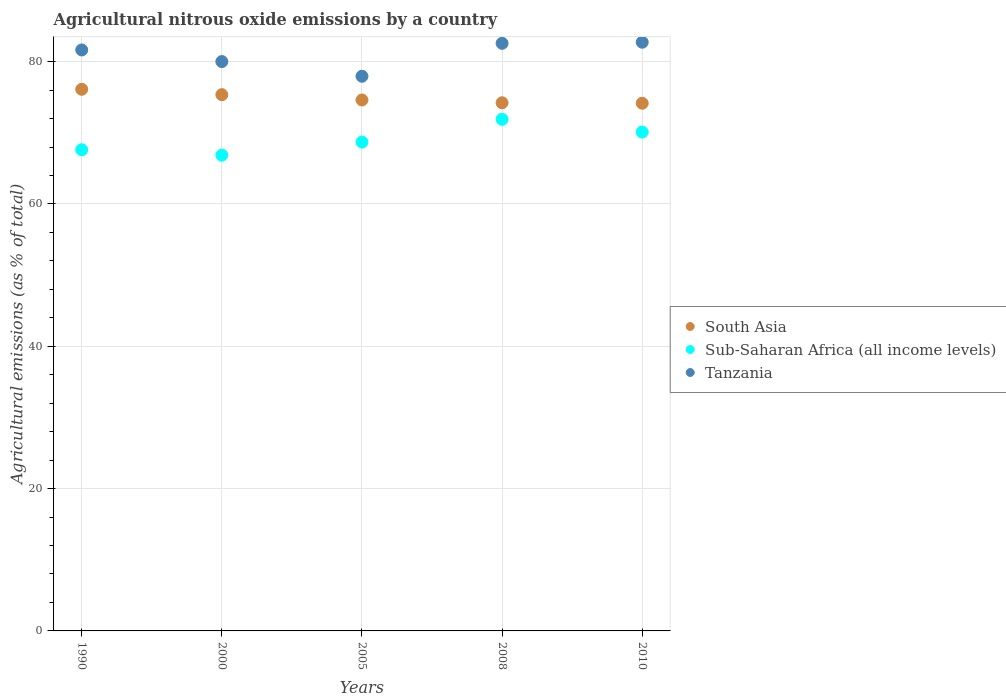How many different coloured dotlines are there?
Keep it short and to the point. 3. Is the number of dotlines equal to the number of legend labels?
Provide a short and direct response. Yes. What is the amount of agricultural nitrous oxide emitted in Sub-Saharan Africa (all income levels) in 2000?
Make the answer very short. 66.86. Across all years, what is the maximum amount of agricultural nitrous oxide emitted in South Asia?
Provide a short and direct response. 76.12. Across all years, what is the minimum amount of agricultural nitrous oxide emitted in Sub-Saharan Africa (all income levels)?
Provide a short and direct response. 66.86. In which year was the amount of agricultural nitrous oxide emitted in Sub-Saharan Africa (all income levels) maximum?
Your answer should be compact. 2008. What is the total amount of agricultural nitrous oxide emitted in South Asia in the graph?
Give a very brief answer. 374.48. What is the difference between the amount of agricultural nitrous oxide emitted in Sub-Saharan Africa (all income levels) in 2008 and that in 2010?
Give a very brief answer. 1.79. What is the difference between the amount of agricultural nitrous oxide emitted in Sub-Saharan Africa (all income levels) in 2005 and the amount of agricultural nitrous oxide emitted in Tanzania in 1990?
Your answer should be compact. -12.95. What is the average amount of agricultural nitrous oxide emitted in Sub-Saharan Africa (all income levels) per year?
Your answer should be compact. 69.04. In the year 2000, what is the difference between the amount of agricultural nitrous oxide emitted in Tanzania and amount of agricultural nitrous oxide emitted in South Asia?
Your answer should be very brief. 4.65. What is the ratio of the amount of agricultural nitrous oxide emitted in Tanzania in 2000 to that in 2005?
Your response must be concise. 1.03. Is the difference between the amount of agricultural nitrous oxide emitted in Tanzania in 1990 and 2000 greater than the difference between the amount of agricultural nitrous oxide emitted in South Asia in 1990 and 2000?
Your answer should be compact. Yes. What is the difference between the highest and the second highest amount of agricultural nitrous oxide emitted in South Asia?
Offer a very short reply. 0.76. What is the difference between the highest and the lowest amount of agricultural nitrous oxide emitted in South Asia?
Keep it short and to the point. 1.96. In how many years, is the amount of agricultural nitrous oxide emitted in Sub-Saharan Africa (all income levels) greater than the average amount of agricultural nitrous oxide emitted in Sub-Saharan Africa (all income levels) taken over all years?
Provide a short and direct response. 2. Does the amount of agricultural nitrous oxide emitted in Tanzania monotonically increase over the years?
Your response must be concise. No. Is the amount of agricultural nitrous oxide emitted in Sub-Saharan Africa (all income levels) strictly less than the amount of agricultural nitrous oxide emitted in South Asia over the years?
Give a very brief answer. Yes. How many dotlines are there?
Ensure brevity in your answer.  3. Are the values on the major ticks of Y-axis written in scientific E-notation?
Provide a succinct answer. No. Does the graph contain grids?
Provide a short and direct response. Yes. Where does the legend appear in the graph?
Offer a very short reply. Center right. How many legend labels are there?
Make the answer very short. 3. What is the title of the graph?
Your answer should be very brief. Agricultural nitrous oxide emissions by a country. Does "Faeroe Islands" appear as one of the legend labels in the graph?
Provide a succinct answer. No. What is the label or title of the Y-axis?
Keep it short and to the point. Agricultural emissions (as % of total). What is the Agricultural emissions (as % of total) of South Asia in 1990?
Your answer should be very brief. 76.12. What is the Agricultural emissions (as % of total) in Sub-Saharan Africa (all income levels) in 1990?
Your response must be concise. 67.62. What is the Agricultural emissions (as % of total) in Tanzania in 1990?
Your response must be concise. 81.65. What is the Agricultural emissions (as % of total) in South Asia in 2000?
Your response must be concise. 75.36. What is the Agricultural emissions (as % of total) in Sub-Saharan Africa (all income levels) in 2000?
Your answer should be compact. 66.86. What is the Agricultural emissions (as % of total) in Tanzania in 2000?
Make the answer very short. 80.01. What is the Agricultural emissions (as % of total) in South Asia in 2005?
Your answer should be compact. 74.62. What is the Agricultural emissions (as % of total) of Sub-Saharan Africa (all income levels) in 2005?
Provide a short and direct response. 68.7. What is the Agricultural emissions (as % of total) in Tanzania in 2005?
Your response must be concise. 77.95. What is the Agricultural emissions (as % of total) of South Asia in 2008?
Provide a short and direct response. 74.22. What is the Agricultural emissions (as % of total) of Sub-Saharan Africa (all income levels) in 2008?
Keep it short and to the point. 71.9. What is the Agricultural emissions (as % of total) of Tanzania in 2008?
Give a very brief answer. 82.58. What is the Agricultural emissions (as % of total) in South Asia in 2010?
Provide a short and direct response. 74.16. What is the Agricultural emissions (as % of total) of Sub-Saharan Africa (all income levels) in 2010?
Provide a short and direct response. 70.1. What is the Agricultural emissions (as % of total) in Tanzania in 2010?
Offer a terse response. 82.73. Across all years, what is the maximum Agricultural emissions (as % of total) in South Asia?
Give a very brief answer. 76.12. Across all years, what is the maximum Agricultural emissions (as % of total) of Sub-Saharan Africa (all income levels)?
Offer a terse response. 71.9. Across all years, what is the maximum Agricultural emissions (as % of total) of Tanzania?
Provide a short and direct response. 82.73. Across all years, what is the minimum Agricultural emissions (as % of total) of South Asia?
Your answer should be compact. 74.16. Across all years, what is the minimum Agricultural emissions (as % of total) in Sub-Saharan Africa (all income levels)?
Give a very brief answer. 66.86. Across all years, what is the minimum Agricultural emissions (as % of total) in Tanzania?
Provide a succinct answer. 77.95. What is the total Agricultural emissions (as % of total) of South Asia in the graph?
Ensure brevity in your answer.  374.48. What is the total Agricultural emissions (as % of total) in Sub-Saharan Africa (all income levels) in the graph?
Provide a short and direct response. 345.18. What is the total Agricultural emissions (as % of total) in Tanzania in the graph?
Offer a terse response. 404.92. What is the difference between the Agricultural emissions (as % of total) of South Asia in 1990 and that in 2000?
Offer a terse response. 0.76. What is the difference between the Agricultural emissions (as % of total) of Sub-Saharan Africa (all income levels) in 1990 and that in 2000?
Offer a very short reply. 0.76. What is the difference between the Agricultural emissions (as % of total) of Tanzania in 1990 and that in 2000?
Your answer should be very brief. 1.63. What is the difference between the Agricultural emissions (as % of total) in South Asia in 1990 and that in 2005?
Keep it short and to the point. 1.5. What is the difference between the Agricultural emissions (as % of total) in Sub-Saharan Africa (all income levels) in 1990 and that in 2005?
Offer a terse response. -1.08. What is the difference between the Agricultural emissions (as % of total) of Tanzania in 1990 and that in 2005?
Keep it short and to the point. 3.7. What is the difference between the Agricultural emissions (as % of total) of South Asia in 1990 and that in 2008?
Your response must be concise. 1.9. What is the difference between the Agricultural emissions (as % of total) in Sub-Saharan Africa (all income levels) in 1990 and that in 2008?
Provide a succinct answer. -4.28. What is the difference between the Agricultural emissions (as % of total) in Tanzania in 1990 and that in 2008?
Offer a terse response. -0.93. What is the difference between the Agricultural emissions (as % of total) in South Asia in 1990 and that in 2010?
Give a very brief answer. 1.96. What is the difference between the Agricultural emissions (as % of total) in Sub-Saharan Africa (all income levels) in 1990 and that in 2010?
Your answer should be compact. -2.48. What is the difference between the Agricultural emissions (as % of total) of Tanzania in 1990 and that in 2010?
Provide a short and direct response. -1.08. What is the difference between the Agricultural emissions (as % of total) in South Asia in 2000 and that in 2005?
Your answer should be compact. 0.75. What is the difference between the Agricultural emissions (as % of total) in Sub-Saharan Africa (all income levels) in 2000 and that in 2005?
Your answer should be compact. -1.84. What is the difference between the Agricultural emissions (as % of total) of Tanzania in 2000 and that in 2005?
Offer a terse response. 2.07. What is the difference between the Agricultural emissions (as % of total) of South Asia in 2000 and that in 2008?
Provide a succinct answer. 1.14. What is the difference between the Agricultural emissions (as % of total) of Sub-Saharan Africa (all income levels) in 2000 and that in 2008?
Give a very brief answer. -5.04. What is the difference between the Agricultural emissions (as % of total) of Tanzania in 2000 and that in 2008?
Give a very brief answer. -2.56. What is the difference between the Agricultural emissions (as % of total) in South Asia in 2000 and that in 2010?
Ensure brevity in your answer.  1.2. What is the difference between the Agricultural emissions (as % of total) of Sub-Saharan Africa (all income levels) in 2000 and that in 2010?
Your answer should be very brief. -3.24. What is the difference between the Agricultural emissions (as % of total) in Tanzania in 2000 and that in 2010?
Your answer should be very brief. -2.72. What is the difference between the Agricultural emissions (as % of total) in South Asia in 2005 and that in 2008?
Your answer should be very brief. 0.39. What is the difference between the Agricultural emissions (as % of total) of Sub-Saharan Africa (all income levels) in 2005 and that in 2008?
Offer a very short reply. -3.2. What is the difference between the Agricultural emissions (as % of total) in Tanzania in 2005 and that in 2008?
Offer a terse response. -4.63. What is the difference between the Agricultural emissions (as % of total) in South Asia in 2005 and that in 2010?
Your answer should be compact. 0.46. What is the difference between the Agricultural emissions (as % of total) of Sub-Saharan Africa (all income levels) in 2005 and that in 2010?
Offer a terse response. -1.41. What is the difference between the Agricultural emissions (as % of total) of Tanzania in 2005 and that in 2010?
Your answer should be compact. -4.79. What is the difference between the Agricultural emissions (as % of total) in South Asia in 2008 and that in 2010?
Make the answer very short. 0.06. What is the difference between the Agricultural emissions (as % of total) of Sub-Saharan Africa (all income levels) in 2008 and that in 2010?
Provide a succinct answer. 1.79. What is the difference between the Agricultural emissions (as % of total) of Tanzania in 2008 and that in 2010?
Offer a very short reply. -0.15. What is the difference between the Agricultural emissions (as % of total) of South Asia in 1990 and the Agricultural emissions (as % of total) of Sub-Saharan Africa (all income levels) in 2000?
Provide a short and direct response. 9.26. What is the difference between the Agricultural emissions (as % of total) in South Asia in 1990 and the Agricultural emissions (as % of total) in Tanzania in 2000?
Provide a short and direct response. -3.9. What is the difference between the Agricultural emissions (as % of total) of Sub-Saharan Africa (all income levels) in 1990 and the Agricultural emissions (as % of total) of Tanzania in 2000?
Make the answer very short. -12.39. What is the difference between the Agricultural emissions (as % of total) of South Asia in 1990 and the Agricultural emissions (as % of total) of Sub-Saharan Africa (all income levels) in 2005?
Offer a very short reply. 7.42. What is the difference between the Agricultural emissions (as % of total) of South Asia in 1990 and the Agricultural emissions (as % of total) of Tanzania in 2005?
Your response must be concise. -1.83. What is the difference between the Agricultural emissions (as % of total) in Sub-Saharan Africa (all income levels) in 1990 and the Agricultural emissions (as % of total) in Tanzania in 2005?
Provide a short and direct response. -10.33. What is the difference between the Agricultural emissions (as % of total) in South Asia in 1990 and the Agricultural emissions (as % of total) in Sub-Saharan Africa (all income levels) in 2008?
Your answer should be compact. 4.22. What is the difference between the Agricultural emissions (as % of total) of South Asia in 1990 and the Agricultural emissions (as % of total) of Tanzania in 2008?
Keep it short and to the point. -6.46. What is the difference between the Agricultural emissions (as % of total) of Sub-Saharan Africa (all income levels) in 1990 and the Agricultural emissions (as % of total) of Tanzania in 2008?
Offer a very short reply. -14.96. What is the difference between the Agricultural emissions (as % of total) of South Asia in 1990 and the Agricultural emissions (as % of total) of Sub-Saharan Africa (all income levels) in 2010?
Your answer should be very brief. 6.02. What is the difference between the Agricultural emissions (as % of total) in South Asia in 1990 and the Agricultural emissions (as % of total) in Tanzania in 2010?
Your answer should be very brief. -6.61. What is the difference between the Agricultural emissions (as % of total) in Sub-Saharan Africa (all income levels) in 1990 and the Agricultural emissions (as % of total) in Tanzania in 2010?
Provide a short and direct response. -15.11. What is the difference between the Agricultural emissions (as % of total) of South Asia in 2000 and the Agricultural emissions (as % of total) of Sub-Saharan Africa (all income levels) in 2005?
Offer a terse response. 6.67. What is the difference between the Agricultural emissions (as % of total) of South Asia in 2000 and the Agricultural emissions (as % of total) of Tanzania in 2005?
Your answer should be compact. -2.58. What is the difference between the Agricultural emissions (as % of total) of Sub-Saharan Africa (all income levels) in 2000 and the Agricultural emissions (as % of total) of Tanzania in 2005?
Keep it short and to the point. -11.09. What is the difference between the Agricultural emissions (as % of total) in South Asia in 2000 and the Agricultural emissions (as % of total) in Sub-Saharan Africa (all income levels) in 2008?
Provide a short and direct response. 3.46. What is the difference between the Agricultural emissions (as % of total) of South Asia in 2000 and the Agricultural emissions (as % of total) of Tanzania in 2008?
Offer a very short reply. -7.22. What is the difference between the Agricultural emissions (as % of total) in Sub-Saharan Africa (all income levels) in 2000 and the Agricultural emissions (as % of total) in Tanzania in 2008?
Your response must be concise. -15.72. What is the difference between the Agricultural emissions (as % of total) in South Asia in 2000 and the Agricultural emissions (as % of total) in Sub-Saharan Africa (all income levels) in 2010?
Provide a succinct answer. 5.26. What is the difference between the Agricultural emissions (as % of total) in South Asia in 2000 and the Agricultural emissions (as % of total) in Tanzania in 2010?
Make the answer very short. -7.37. What is the difference between the Agricultural emissions (as % of total) in Sub-Saharan Africa (all income levels) in 2000 and the Agricultural emissions (as % of total) in Tanzania in 2010?
Keep it short and to the point. -15.87. What is the difference between the Agricultural emissions (as % of total) in South Asia in 2005 and the Agricultural emissions (as % of total) in Sub-Saharan Africa (all income levels) in 2008?
Your answer should be compact. 2.72. What is the difference between the Agricultural emissions (as % of total) in South Asia in 2005 and the Agricultural emissions (as % of total) in Tanzania in 2008?
Offer a very short reply. -7.96. What is the difference between the Agricultural emissions (as % of total) in Sub-Saharan Africa (all income levels) in 2005 and the Agricultural emissions (as % of total) in Tanzania in 2008?
Ensure brevity in your answer.  -13.88. What is the difference between the Agricultural emissions (as % of total) of South Asia in 2005 and the Agricultural emissions (as % of total) of Sub-Saharan Africa (all income levels) in 2010?
Ensure brevity in your answer.  4.51. What is the difference between the Agricultural emissions (as % of total) of South Asia in 2005 and the Agricultural emissions (as % of total) of Tanzania in 2010?
Make the answer very short. -8.12. What is the difference between the Agricultural emissions (as % of total) of Sub-Saharan Africa (all income levels) in 2005 and the Agricultural emissions (as % of total) of Tanzania in 2010?
Your answer should be very brief. -14.04. What is the difference between the Agricultural emissions (as % of total) in South Asia in 2008 and the Agricultural emissions (as % of total) in Sub-Saharan Africa (all income levels) in 2010?
Provide a succinct answer. 4.12. What is the difference between the Agricultural emissions (as % of total) of South Asia in 2008 and the Agricultural emissions (as % of total) of Tanzania in 2010?
Ensure brevity in your answer.  -8.51. What is the difference between the Agricultural emissions (as % of total) of Sub-Saharan Africa (all income levels) in 2008 and the Agricultural emissions (as % of total) of Tanzania in 2010?
Your response must be concise. -10.83. What is the average Agricultural emissions (as % of total) of South Asia per year?
Make the answer very short. 74.9. What is the average Agricultural emissions (as % of total) in Sub-Saharan Africa (all income levels) per year?
Your answer should be compact. 69.04. What is the average Agricultural emissions (as % of total) of Tanzania per year?
Your answer should be very brief. 80.98. In the year 1990, what is the difference between the Agricultural emissions (as % of total) in South Asia and Agricultural emissions (as % of total) in Sub-Saharan Africa (all income levels)?
Offer a terse response. 8.5. In the year 1990, what is the difference between the Agricultural emissions (as % of total) in South Asia and Agricultural emissions (as % of total) in Tanzania?
Offer a terse response. -5.53. In the year 1990, what is the difference between the Agricultural emissions (as % of total) in Sub-Saharan Africa (all income levels) and Agricultural emissions (as % of total) in Tanzania?
Keep it short and to the point. -14.03. In the year 2000, what is the difference between the Agricultural emissions (as % of total) of South Asia and Agricultural emissions (as % of total) of Sub-Saharan Africa (all income levels)?
Your answer should be very brief. 8.5. In the year 2000, what is the difference between the Agricultural emissions (as % of total) in South Asia and Agricultural emissions (as % of total) in Tanzania?
Your answer should be compact. -4.65. In the year 2000, what is the difference between the Agricultural emissions (as % of total) in Sub-Saharan Africa (all income levels) and Agricultural emissions (as % of total) in Tanzania?
Offer a very short reply. -13.16. In the year 2005, what is the difference between the Agricultural emissions (as % of total) in South Asia and Agricultural emissions (as % of total) in Sub-Saharan Africa (all income levels)?
Offer a terse response. 5.92. In the year 2005, what is the difference between the Agricultural emissions (as % of total) of South Asia and Agricultural emissions (as % of total) of Tanzania?
Give a very brief answer. -3.33. In the year 2005, what is the difference between the Agricultural emissions (as % of total) in Sub-Saharan Africa (all income levels) and Agricultural emissions (as % of total) in Tanzania?
Ensure brevity in your answer.  -9.25. In the year 2008, what is the difference between the Agricultural emissions (as % of total) in South Asia and Agricultural emissions (as % of total) in Sub-Saharan Africa (all income levels)?
Your answer should be very brief. 2.32. In the year 2008, what is the difference between the Agricultural emissions (as % of total) of South Asia and Agricultural emissions (as % of total) of Tanzania?
Your answer should be very brief. -8.36. In the year 2008, what is the difference between the Agricultural emissions (as % of total) of Sub-Saharan Africa (all income levels) and Agricultural emissions (as % of total) of Tanzania?
Make the answer very short. -10.68. In the year 2010, what is the difference between the Agricultural emissions (as % of total) of South Asia and Agricultural emissions (as % of total) of Sub-Saharan Africa (all income levels)?
Make the answer very short. 4.06. In the year 2010, what is the difference between the Agricultural emissions (as % of total) in South Asia and Agricultural emissions (as % of total) in Tanzania?
Give a very brief answer. -8.57. In the year 2010, what is the difference between the Agricultural emissions (as % of total) of Sub-Saharan Africa (all income levels) and Agricultural emissions (as % of total) of Tanzania?
Your response must be concise. -12.63. What is the ratio of the Agricultural emissions (as % of total) in Sub-Saharan Africa (all income levels) in 1990 to that in 2000?
Provide a short and direct response. 1.01. What is the ratio of the Agricultural emissions (as % of total) in Tanzania in 1990 to that in 2000?
Your answer should be very brief. 1.02. What is the ratio of the Agricultural emissions (as % of total) of South Asia in 1990 to that in 2005?
Give a very brief answer. 1.02. What is the ratio of the Agricultural emissions (as % of total) in Sub-Saharan Africa (all income levels) in 1990 to that in 2005?
Ensure brevity in your answer.  0.98. What is the ratio of the Agricultural emissions (as % of total) in Tanzania in 1990 to that in 2005?
Your answer should be compact. 1.05. What is the ratio of the Agricultural emissions (as % of total) in South Asia in 1990 to that in 2008?
Offer a very short reply. 1.03. What is the ratio of the Agricultural emissions (as % of total) of Sub-Saharan Africa (all income levels) in 1990 to that in 2008?
Your response must be concise. 0.94. What is the ratio of the Agricultural emissions (as % of total) in Tanzania in 1990 to that in 2008?
Your answer should be very brief. 0.99. What is the ratio of the Agricultural emissions (as % of total) in South Asia in 1990 to that in 2010?
Your answer should be compact. 1.03. What is the ratio of the Agricultural emissions (as % of total) in Sub-Saharan Africa (all income levels) in 1990 to that in 2010?
Your answer should be very brief. 0.96. What is the ratio of the Agricultural emissions (as % of total) in Tanzania in 1990 to that in 2010?
Give a very brief answer. 0.99. What is the ratio of the Agricultural emissions (as % of total) in Sub-Saharan Africa (all income levels) in 2000 to that in 2005?
Provide a succinct answer. 0.97. What is the ratio of the Agricultural emissions (as % of total) in Tanzania in 2000 to that in 2005?
Offer a very short reply. 1.03. What is the ratio of the Agricultural emissions (as % of total) of South Asia in 2000 to that in 2008?
Offer a terse response. 1.02. What is the ratio of the Agricultural emissions (as % of total) of Sub-Saharan Africa (all income levels) in 2000 to that in 2008?
Provide a short and direct response. 0.93. What is the ratio of the Agricultural emissions (as % of total) of Tanzania in 2000 to that in 2008?
Make the answer very short. 0.97. What is the ratio of the Agricultural emissions (as % of total) in South Asia in 2000 to that in 2010?
Give a very brief answer. 1.02. What is the ratio of the Agricultural emissions (as % of total) in Sub-Saharan Africa (all income levels) in 2000 to that in 2010?
Offer a terse response. 0.95. What is the ratio of the Agricultural emissions (as % of total) of Tanzania in 2000 to that in 2010?
Your answer should be compact. 0.97. What is the ratio of the Agricultural emissions (as % of total) of South Asia in 2005 to that in 2008?
Offer a very short reply. 1.01. What is the ratio of the Agricultural emissions (as % of total) in Sub-Saharan Africa (all income levels) in 2005 to that in 2008?
Offer a terse response. 0.96. What is the ratio of the Agricultural emissions (as % of total) in Tanzania in 2005 to that in 2008?
Your answer should be very brief. 0.94. What is the ratio of the Agricultural emissions (as % of total) of Sub-Saharan Africa (all income levels) in 2005 to that in 2010?
Make the answer very short. 0.98. What is the ratio of the Agricultural emissions (as % of total) in Tanzania in 2005 to that in 2010?
Make the answer very short. 0.94. What is the ratio of the Agricultural emissions (as % of total) of South Asia in 2008 to that in 2010?
Give a very brief answer. 1. What is the ratio of the Agricultural emissions (as % of total) in Sub-Saharan Africa (all income levels) in 2008 to that in 2010?
Provide a succinct answer. 1.03. What is the ratio of the Agricultural emissions (as % of total) in Tanzania in 2008 to that in 2010?
Keep it short and to the point. 1. What is the difference between the highest and the second highest Agricultural emissions (as % of total) of South Asia?
Provide a short and direct response. 0.76. What is the difference between the highest and the second highest Agricultural emissions (as % of total) of Sub-Saharan Africa (all income levels)?
Your answer should be compact. 1.79. What is the difference between the highest and the second highest Agricultural emissions (as % of total) in Tanzania?
Your answer should be very brief. 0.15. What is the difference between the highest and the lowest Agricultural emissions (as % of total) of South Asia?
Provide a succinct answer. 1.96. What is the difference between the highest and the lowest Agricultural emissions (as % of total) in Sub-Saharan Africa (all income levels)?
Offer a terse response. 5.04. What is the difference between the highest and the lowest Agricultural emissions (as % of total) in Tanzania?
Your response must be concise. 4.79. 